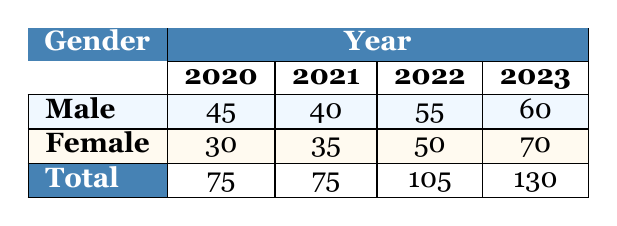What was the enrollment for female students in 2021? The table shows that for the year 2021, the enrollment for female students is listed as 35.
Answer: 35 What is the total enrollment of male students from 2020 to 2023? We can find the total enrollment of male students by adding their enrollments for each year: 45 (2020) + 40 (2021) + 55 (2022) + 60 (2023) = 200.
Answer: 200 Is the enrollment of male students higher than that of female students in 2022? In 2022, the enrollment for male students is 55 and for female students is 50. Since 55 is greater than 50, the statement is true.
Answer: Yes What was the percentage increase in female enrollment from 2020 to 2023? The enrollment for female students in 2020 was 30 and in 2023 it was 70. The increase is 70 - 30 = 40. To find the percentage increase: (40 / 30) * 100 = 133.33%.
Answer: 133.33% Which gender had the highest total enrollment over the four years? We find the total for each gender: Male: 45 + 40 + 55 + 60 = 200; Female: 30 + 35 + 50 + 70 = 185. Since 200 is greater than 185, male students had the highest total enrollment.
Answer: Male What is the average enrollment of female students across all years? To find the average enrollment for female students, we first sum the enrollments: 30 (2020) + 35 (2021) + 50 (2022) + 70 (2023) = 185. Then, we divide by the number of years: 185 / 4 = 46.25.
Answer: 46.25 Did the total enrollment increase every year from 2020 to 2023? We can check the total for each year: 75 (2020), 75 (2021), 105 (2022), and 130 (2023). The total remained the same from 2020 to 2021 and then increased afterward, indicating that the total did not increase every year.
Answer: No What is the difference in enrollment between the years 2022 and 2023 for female students? The enrollment for female students in 2022 is 50, and in 2023 it is 70. The difference is 70 - 50 = 20.
Answer: 20 What percentage of the total enrollment in 2023 was female? In 2023, the total enrollment is 60 (male) + 70 (female) = 130. To find the percentage of female students: (70 / 130) * 100 = 53.85%.
Answer: 53.85% 